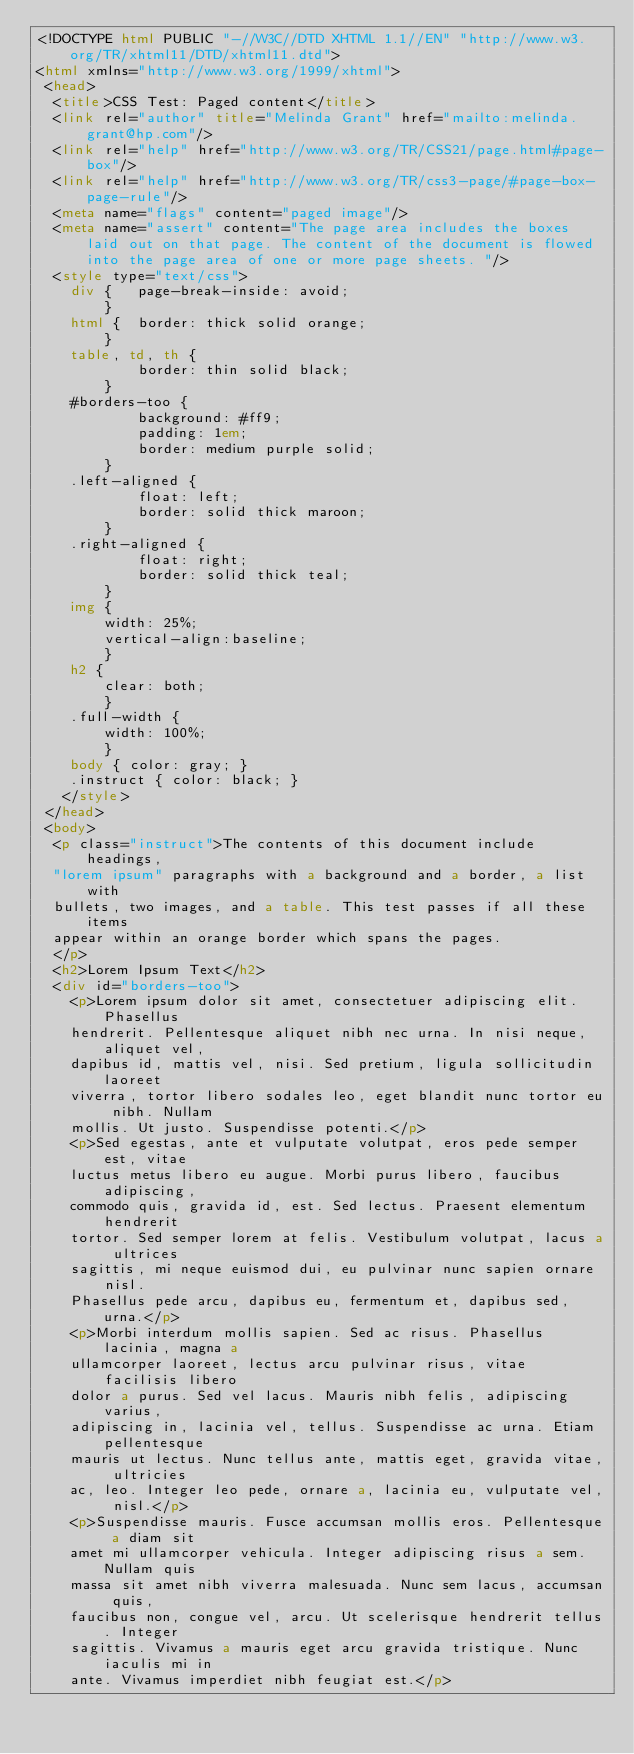<code> <loc_0><loc_0><loc_500><loc_500><_HTML_><!DOCTYPE html PUBLIC "-//W3C//DTD XHTML 1.1//EN" "http://www.w3.org/TR/xhtml11/DTD/xhtml11.dtd">
<html xmlns="http://www.w3.org/1999/xhtml">
 <head>
  <title>CSS Test: Paged content</title>
  <link rel="author" title="Melinda Grant" href="mailto:melinda.grant@hp.com"/>
  <link rel="help" href="http://www.w3.org/TR/CSS21/page.html#page-box"/>
  <link rel="help" href="http://www.w3.org/TR/css3-page/#page-box-page-rule"/>
  <meta name="flags" content="paged image"/>
  <meta name="assert" content="The page area includes the boxes laid out on that page. The content of the document is flowed into the page area of one or more page sheets. "/>
  <style type="text/css">
    div {   page-break-inside: avoid;
        }
    html {  border: thick solid orange;
        }
    table, td, th {
            border: thin solid black;
        }
    #borders-too {
            background: #ff9;
            padding: 1em;
            border: medium purple solid;
        }
    .left-aligned {
            float: left;
            border: solid thick maroon;
        }
    .right-aligned {
            float: right;
            border: solid thick teal;
        }
    img {
        width: 25%;
        vertical-align:baseline;
        }
    h2 {
        clear: both;
        }
    .full-width {
        width: 100%;
        }
    body { color: gray; }
		.instruct { color: black; }
   </style>
 </head>
 <body>
  <p class="instruct">The contents of this document include headings,
	"lorem ipsum" paragraphs with a background and a border, a list with
	bullets, two images, and a table. This test passes if all these items
	appear within an orange border which spans the pages.
  </p>
  <h2>Lorem Ipsum Text</h2>
  <div id="borders-too">
	  <p>Lorem ipsum dolor sit amet, consectetuer adipiscing elit. Phasellus
	  hendrerit. Pellentesque aliquet nibh nec urna. In nisi neque, aliquet vel,
	  dapibus id, mattis vel, nisi. Sed pretium, ligula sollicitudin laoreet
	  viverra, tortor libero sodales leo, eget blandit nunc tortor eu nibh. Nullam
	  mollis. Ut justo. Suspendisse potenti.</p>
	  <p>Sed egestas, ante et vulputate volutpat, eros pede semper est, vitae
	  luctus metus libero eu augue. Morbi purus libero, faucibus adipiscing,
	  commodo quis, gravida id, est. Sed lectus. Praesent elementum hendrerit
	  tortor. Sed semper lorem at felis. Vestibulum volutpat, lacus a ultrices
	  sagittis, mi neque euismod dui, eu pulvinar nunc sapien ornare nisl.
	  Phasellus pede arcu, dapibus eu, fermentum et, dapibus sed, urna.</p>
	  <p>Morbi interdum mollis sapien. Sed ac risus. Phasellus lacinia, magna a
	  ullamcorper laoreet, lectus arcu pulvinar risus, vitae facilisis libero
	  dolor a purus. Sed vel lacus. Mauris nibh felis, adipiscing varius,
	  adipiscing in, lacinia vel, tellus. Suspendisse ac urna. Etiam pellentesque
	  mauris ut lectus. Nunc tellus ante, mattis eget, gravida vitae, ultricies
	  ac, leo. Integer leo pede, ornare a, lacinia eu, vulputate vel, nisl.</p>
	  <p>Suspendisse mauris. Fusce accumsan mollis eros. Pellentesque a diam sit
	  amet mi ullamcorper vehicula. Integer adipiscing risus a sem. Nullam quis
	  massa sit amet nibh viverra malesuada. Nunc sem lacus, accumsan quis,
	  faucibus non, congue vel, arcu. Ut scelerisque hendrerit tellus. Integer
	  sagittis. Vivamus a mauris eget arcu gravida tristique. Nunc iaculis mi in
	  ante. Vivamus imperdiet nibh feugiat est.</p></code> 